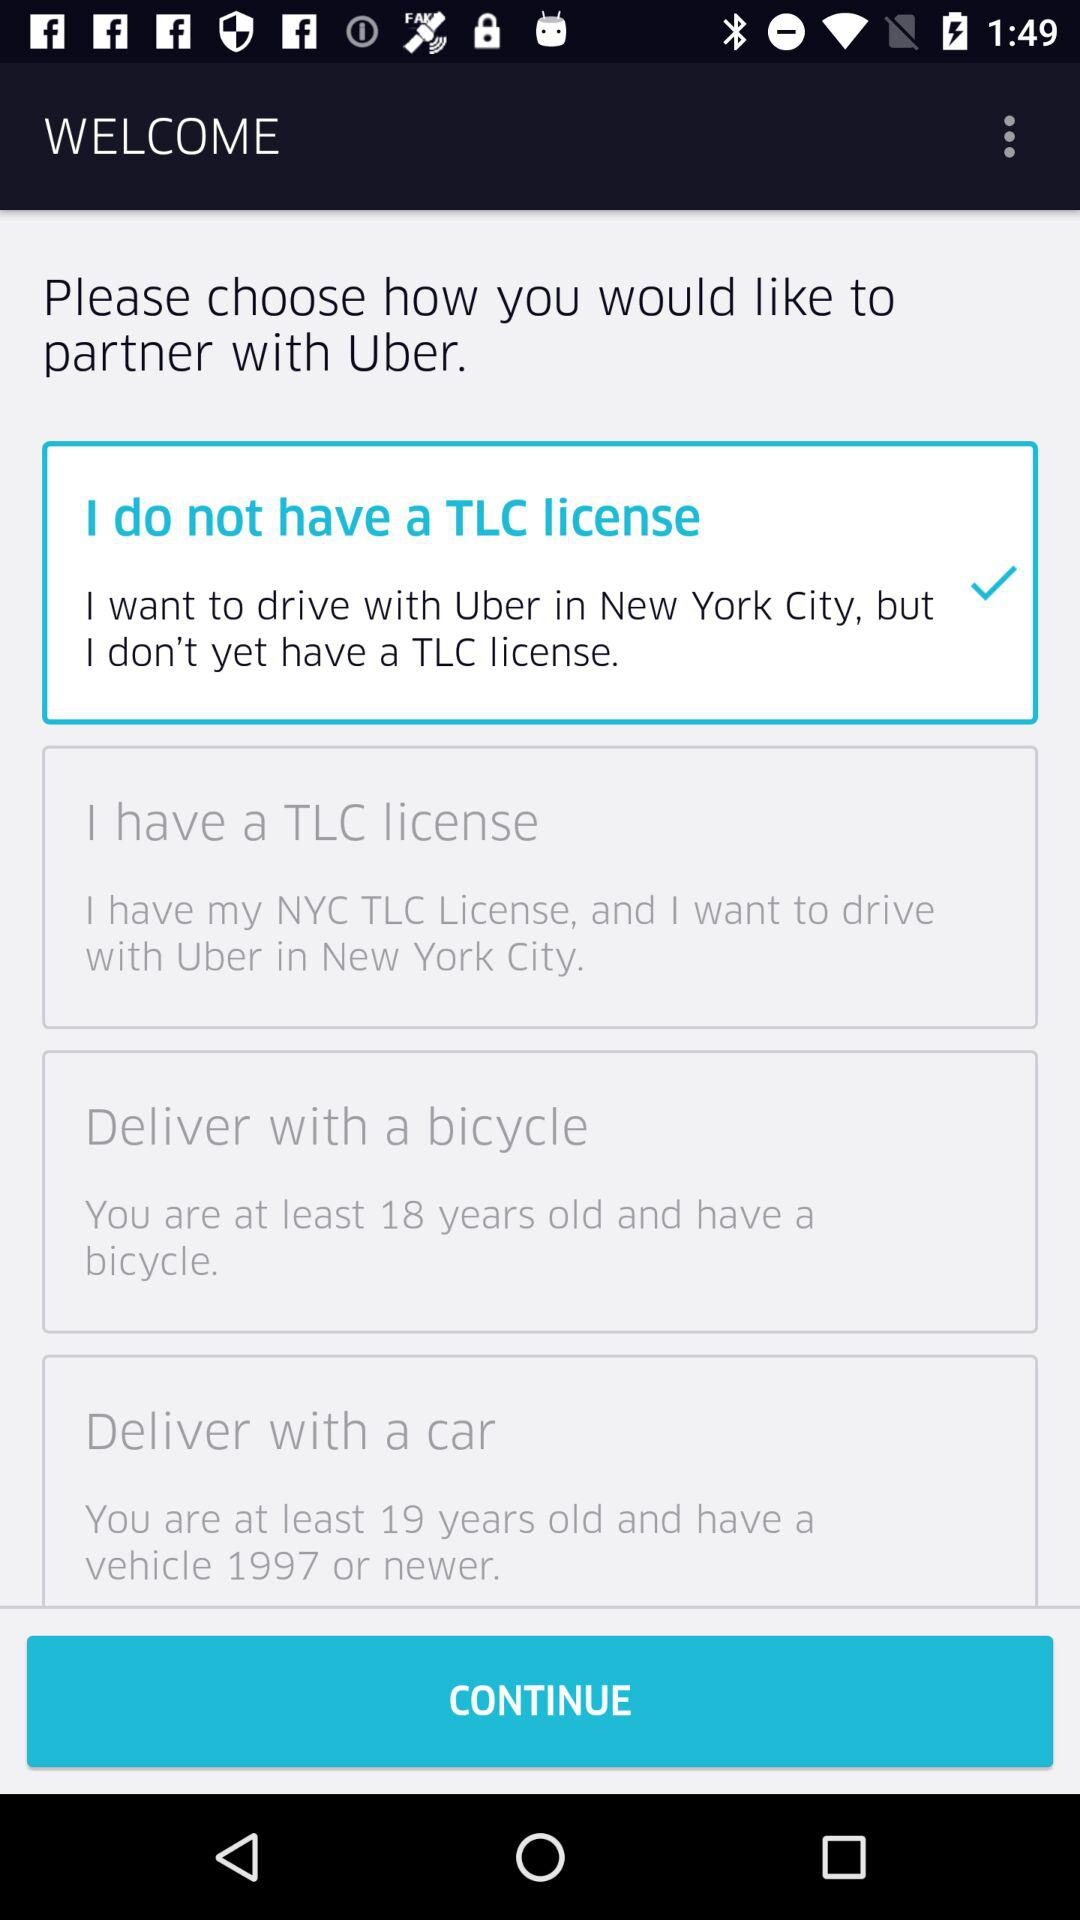Which option is selected? The selected option is "I do not have a TLC license". 